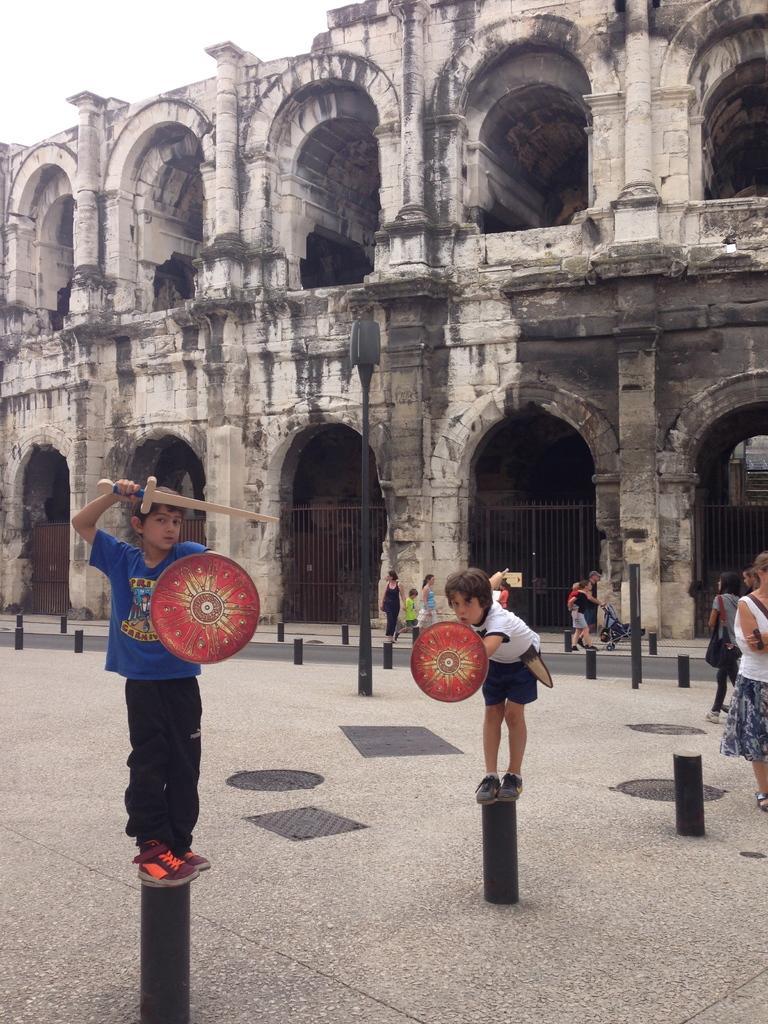How would you summarize this image in a sentence or two? In this image in the center there are persons standing. In the background there is a building and there are gates and there are small poles. On the right side there are persons standing and walking and in the front the kids are holding object which red in colour and standing on the poles. 